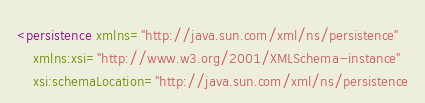Convert code to text. <code><loc_0><loc_0><loc_500><loc_500><_XML_><persistence xmlns="http://java.sun.com/xml/ns/persistence"
	xmlns:xsi="http://www.w3.org/2001/XMLSchema-instance"
	xsi:schemaLocation="http://java.sun.com/xml/ns/persistence</code> 